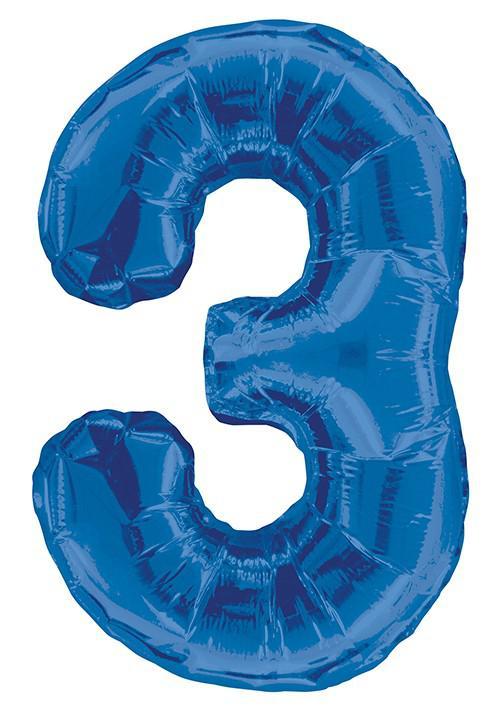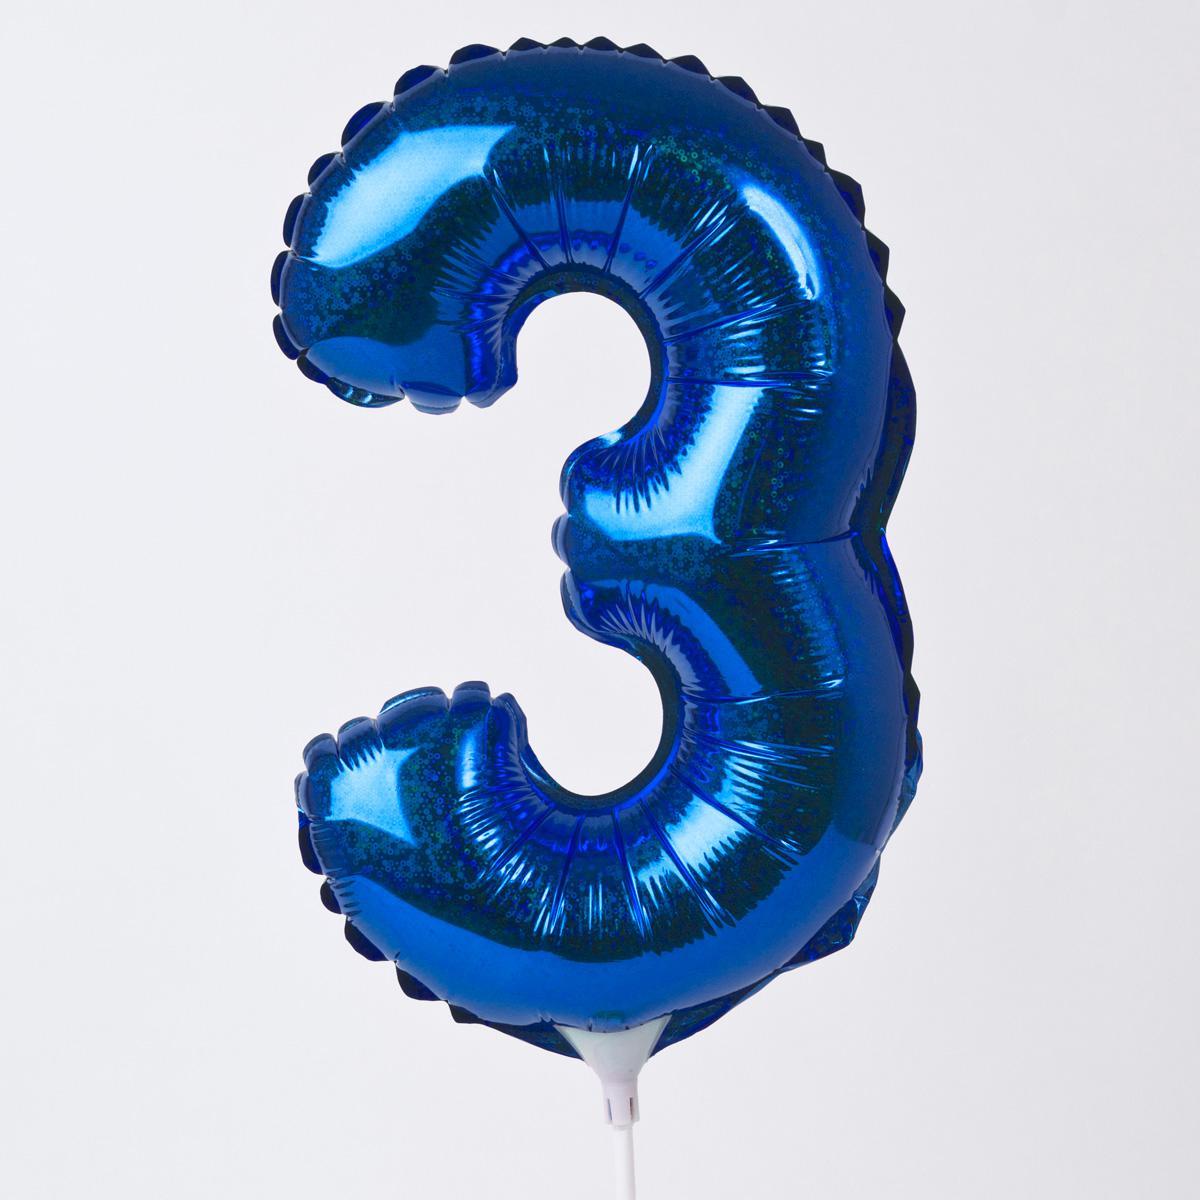The first image is the image on the left, the second image is the image on the right. Analyze the images presented: Is the assertion "All the number three balloons are blue." valid? Answer yes or no. Yes. The first image is the image on the left, the second image is the image on the right. For the images displayed, is the sentence "Each image contains exactly one purple item shaped like the number three." factually correct? Answer yes or no. No. 